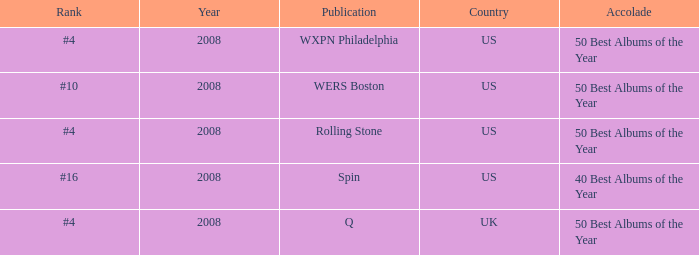Which rank's country is the US when the accolade is 40 best albums of the year? #16. 